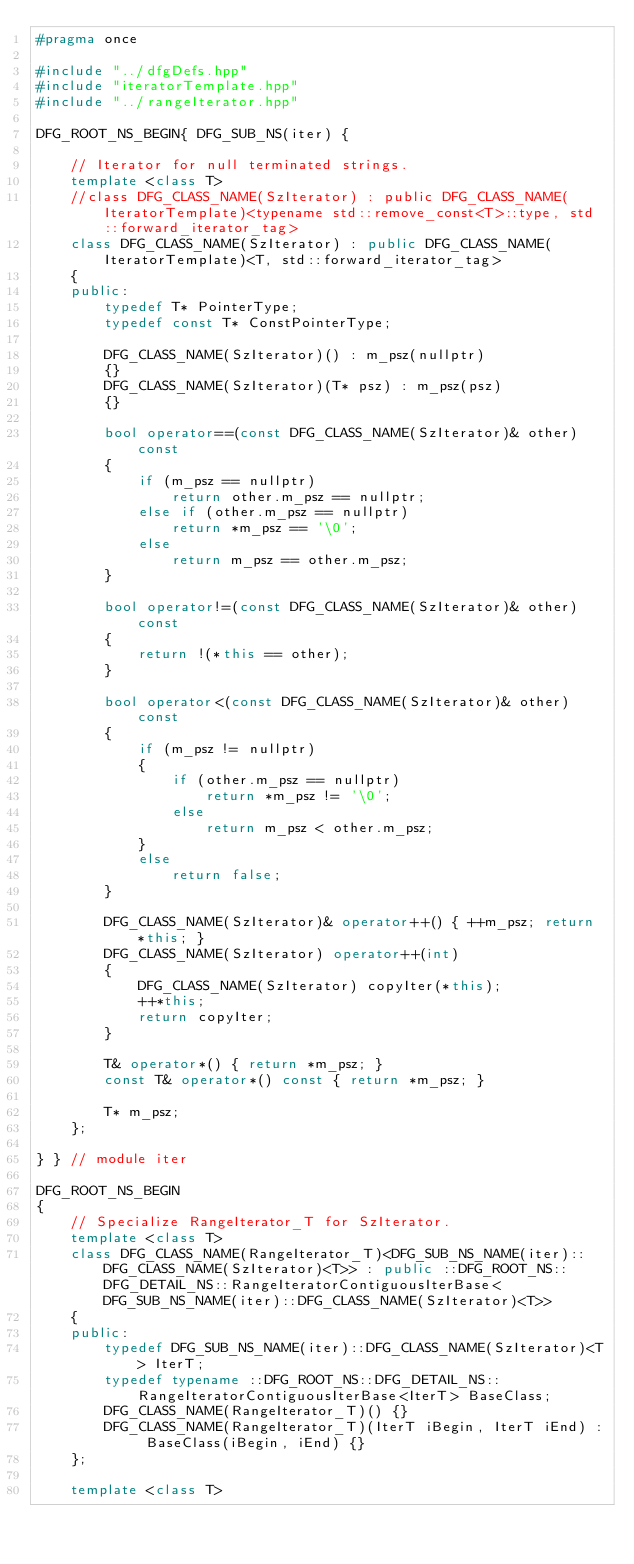Convert code to text. <code><loc_0><loc_0><loc_500><loc_500><_C++_>#pragma once

#include "../dfgDefs.hpp"
#include "iteratorTemplate.hpp"
#include "../rangeIterator.hpp"

DFG_ROOT_NS_BEGIN{ DFG_SUB_NS(iter) {

	// Iterator for null terminated strings.
	template <class T>
	//class DFG_CLASS_NAME(SzIterator) : public DFG_CLASS_NAME(IteratorTemplate)<typename std::remove_const<T>::type, std::forward_iterator_tag>
    class DFG_CLASS_NAME(SzIterator) : public DFG_CLASS_NAME(IteratorTemplate)<T, std::forward_iterator_tag>
	{
	public:
		typedef T* PointerType;
		typedef const T* ConstPointerType;

		DFG_CLASS_NAME(SzIterator)() : m_psz(nullptr)
		{}
		DFG_CLASS_NAME(SzIterator)(T* psz) : m_psz(psz)
		{}

		bool operator==(const DFG_CLASS_NAME(SzIterator)& other) const
		{
			if (m_psz == nullptr)
				return other.m_psz == nullptr;
			else if (other.m_psz == nullptr)
				return *m_psz == '\0';
			else
				return m_psz == other.m_psz;
		}

		bool operator!=(const DFG_CLASS_NAME(SzIterator)& other) const
		{
			return !(*this == other);
		}

		bool operator<(const DFG_CLASS_NAME(SzIterator)& other) const
		{
            if (m_psz != nullptr)
            {
                if (other.m_psz == nullptr)
                    return *m_psz != '\0';
                else
                    return m_psz < other.m_psz;
            }
            else
                return false;
		}

		DFG_CLASS_NAME(SzIterator)& operator++() { ++m_psz; return *this; }
		DFG_CLASS_NAME(SzIterator) operator++(int)
		{ 
			DFG_CLASS_NAME(SzIterator) copyIter(*this);
			++*this;
			return copyIter;
		}

		T& operator*() { return *m_psz; }
		const T& operator*() const { return *m_psz; }

		T* m_psz;
	};

} } // module iter

DFG_ROOT_NS_BEGIN
{
    // Specialize RangeIterator_T for SzIterator.
    template <class T>
    class DFG_CLASS_NAME(RangeIterator_T)<DFG_SUB_NS_NAME(iter)::DFG_CLASS_NAME(SzIterator)<T>> : public ::DFG_ROOT_NS::DFG_DETAIL_NS::RangeIteratorContiguousIterBase<DFG_SUB_NS_NAME(iter)::DFG_CLASS_NAME(SzIterator)<T>>
    {
    public:
        typedef DFG_SUB_NS_NAME(iter)::DFG_CLASS_NAME(SzIterator)<T> IterT;
        typedef typename ::DFG_ROOT_NS::DFG_DETAIL_NS::RangeIteratorContiguousIterBase<IterT> BaseClass;
        DFG_CLASS_NAME(RangeIterator_T)() {}
        DFG_CLASS_NAME(RangeIterator_T)(IterT iBegin, IterT iEnd) : BaseClass(iBegin, iEnd) {}
    };

	template <class T></code> 